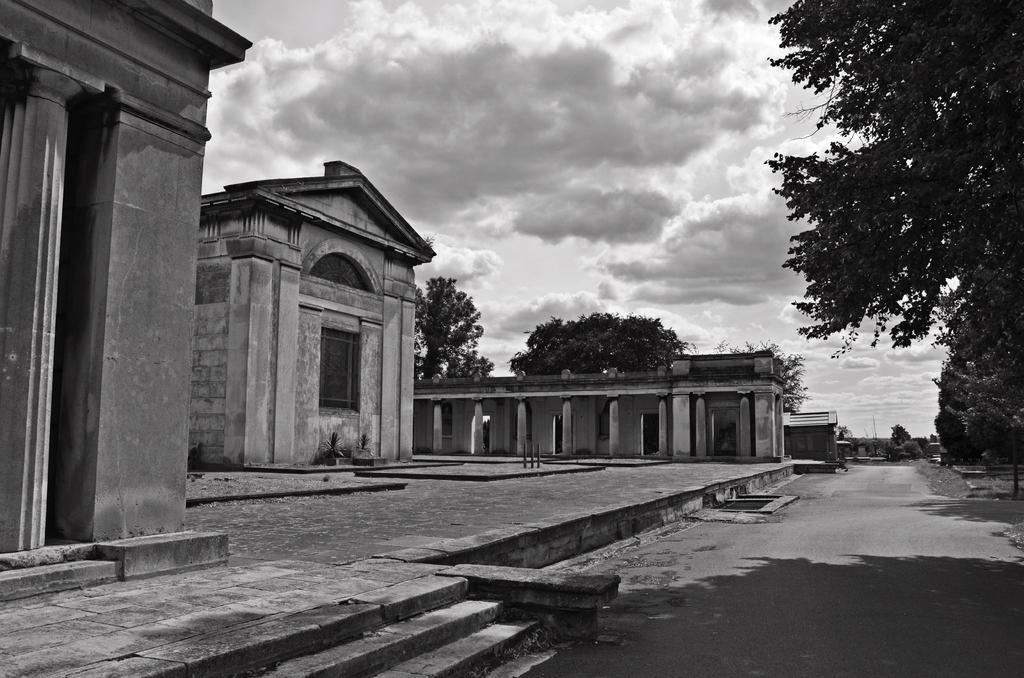What type of structures are present in the image? There are buildings in the image. What other natural elements can be seen in the image? There are trees in the image. What is visible in the background of the image? The sky is visible in the background of the image. What type of pen is being used to draw the clouds in the image? There are no clouds or pens present in the image; it features buildings and trees with the sky visible in the background. 